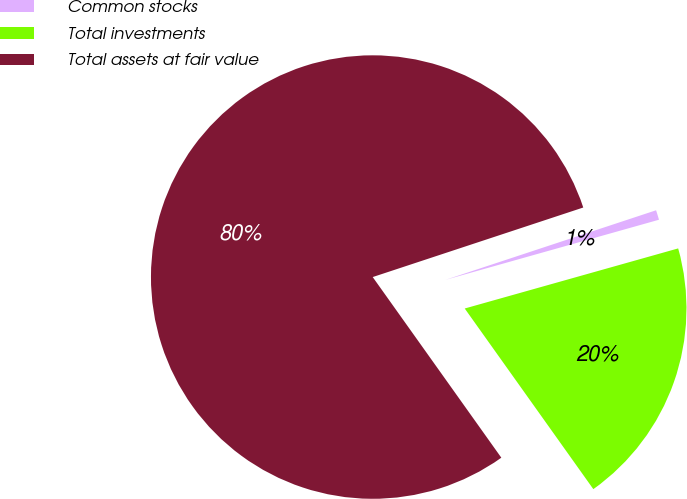Convert chart to OTSL. <chart><loc_0><loc_0><loc_500><loc_500><pie_chart><fcel>Common stocks<fcel>Total investments<fcel>Total assets at fair value<nl><fcel>0.71%<fcel>19.52%<fcel>79.77%<nl></chart> 